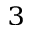<formula> <loc_0><loc_0><loc_500><loc_500>_ { 3 }</formula> 